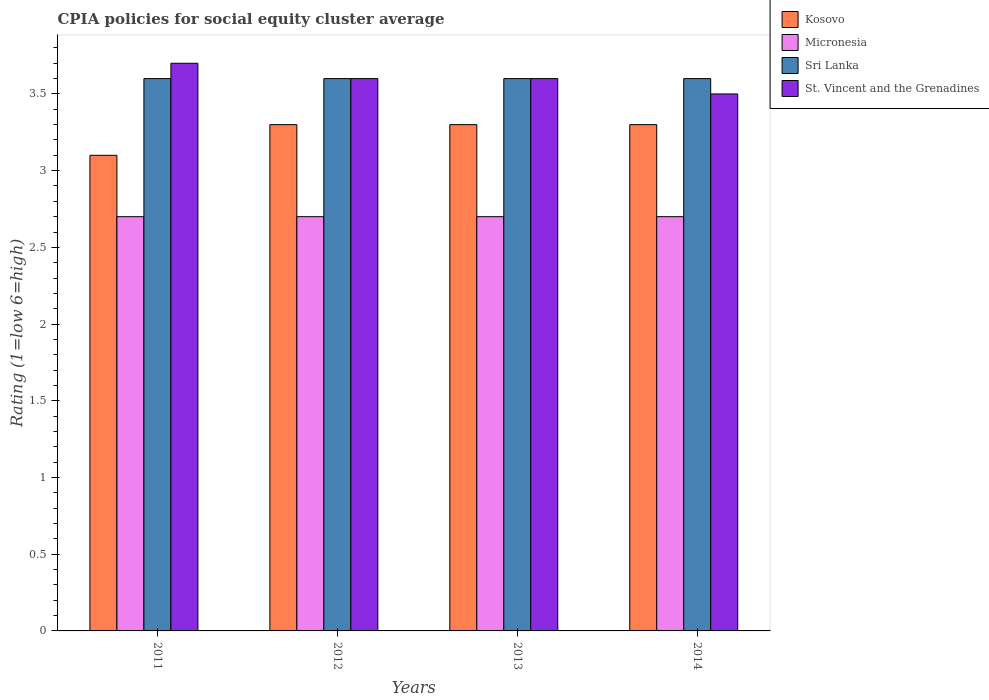How many different coloured bars are there?
Keep it short and to the point. 4. How many bars are there on the 2nd tick from the left?
Your answer should be very brief. 4. How many bars are there on the 1st tick from the right?
Offer a terse response. 4. In how many cases, is the number of bars for a given year not equal to the number of legend labels?
Offer a very short reply. 0. What is the CPIA rating in Kosovo in 2012?
Provide a succinct answer. 3.3. Across all years, what is the maximum CPIA rating in Micronesia?
Offer a terse response. 2.7. Across all years, what is the minimum CPIA rating in Kosovo?
Your answer should be compact. 3.1. In which year was the CPIA rating in Sri Lanka maximum?
Your answer should be very brief. 2011. What is the total CPIA rating in Kosovo in the graph?
Provide a short and direct response. 13. What is the difference between the CPIA rating in St. Vincent and the Grenadines in 2014 and the CPIA rating in Kosovo in 2013?
Keep it short and to the point. 0.2. In the year 2014, what is the difference between the CPIA rating in Sri Lanka and CPIA rating in Micronesia?
Give a very brief answer. 0.9. In how many years, is the CPIA rating in Sri Lanka greater than 2.7?
Ensure brevity in your answer.  4. What is the ratio of the CPIA rating in Kosovo in 2011 to that in 2012?
Your response must be concise. 0.94. What is the difference between the highest and the second highest CPIA rating in St. Vincent and the Grenadines?
Provide a succinct answer. 0.1. What is the difference between the highest and the lowest CPIA rating in St. Vincent and the Grenadines?
Make the answer very short. 0.2. In how many years, is the CPIA rating in Micronesia greater than the average CPIA rating in Micronesia taken over all years?
Provide a short and direct response. 0. Is it the case that in every year, the sum of the CPIA rating in Sri Lanka and CPIA rating in St. Vincent and the Grenadines is greater than the sum of CPIA rating in Kosovo and CPIA rating in Micronesia?
Your response must be concise. Yes. What does the 3rd bar from the left in 2012 represents?
Provide a succinct answer. Sri Lanka. What does the 1st bar from the right in 2012 represents?
Provide a succinct answer. St. Vincent and the Grenadines. Is it the case that in every year, the sum of the CPIA rating in Kosovo and CPIA rating in Sri Lanka is greater than the CPIA rating in Micronesia?
Offer a terse response. Yes. How many bars are there?
Your answer should be compact. 16. What is the difference between two consecutive major ticks on the Y-axis?
Keep it short and to the point. 0.5. How many legend labels are there?
Offer a very short reply. 4. How are the legend labels stacked?
Ensure brevity in your answer.  Vertical. What is the title of the graph?
Your response must be concise. CPIA policies for social equity cluster average. Does "India" appear as one of the legend labels in the graph?
Make the answer very short. No. What is the label or title of the X-axis?
Give a very brief answer. Years. What is the Rating (1=low 6=high) of Micronesia in 2011?
Your response must be concise. 2.7. What is the Rating (1=low 6=high) in Sri Lanka in 2012?
Keep it short and to the point. 3.6. What is the Rating (1=low 6=high) in Kosovo in 2013?
Ensure brevity in your answer.  3.3. What is the Rating (1=low 6=high) of Sri Lanka in 2013?
Provide a short and direct response. 3.6. What is the Rating (1=low 6=high) of St. Vincent and the Grenadines in 2014?
Offer a terse response. 3.5. Across all years, what is the maximum Rating (1=low 6=high) in Kosovo?
Provide a short and direct response. 3.3. Across all years, what is the maximum Rating (1=low 6=high) in Micronesia?
Offer a terse response. 2.7. Across all years, what is the maximum Rating (1=low 6=high) in Sri Lanka?
Your answer should be very brief. 3.6. Across all years, what is the maximum Rating (1=low 6=high) of St. Vincent and the Grenadines?
Make the answer very short. 3.7. Across all years, what is the minimum Rating (1=low 6=high) in Kosovo?
Keep it short and to the point. 3.1. Across all years, what is the minimum Rating (1=low 6=high) of Micronesia?
Ensure brevity in your answer.  2.7. Across all years, what is the minimum Rating (1=low 6=high) in St. Vincent and the Grenadines?
Give a very brief answer. 3.5. What is the total Rating (1=low 6=high) in St. Vincent and the Grenadines in the graph?
Offer a terse response. 14.4. What is the difference between the Rating (1=low 6=high) of Kosovo in 2011 and that in 2012?
Keep it short and to the point. -0.2. What is the difference between the Rating (1=low 6=high) of Micronesia in 2011 and that in 2012?
Your response must be concise. 0. What is the difference between the Rating (1=low 6=high) of St. Vincent and the Grenadines in 2011 and that in 2012?
Offer a terse response. 0.1. What is the difference between the Rating (1=low 6=high) of Kosovo in 2011 and that in 2013?
Offer a terse response. -0.2. What is the difference between the Rating (1=low 6=high) of Micronesia in 2011 and that in 2014?
Provide a short and direct response. 0. What is the difference between the Rating (1=low 6=high) in Sri Lanka in 2011 and that in 2014?
Your answer should be very brief. 0. What is the difference between the Rating (1=low 6=high) in St. Vincent and the Grenadines in 2011 and that in 2014?
Offer a very short reply. 0.2. What is the difference between the Rating (1=low 6=high) of Kosovo in 2012 and that in 2013?
Offer a very short reply. 0. What is the difference between the Rating (1=low 6=high) in Sri Lanka in 2012 and that in 2013?
Offer a terse response. 0. What is the difference between the Rating (1=low 6=high) in Kosovo in 2012 and that in 2014?
Provide a succinct answer. 0. What is the difference between the Rating (1=low 6=high) in Sri Lanka in 2012 and that in 2014?
Your answer should be very brief. 0. What is the difference between the Rating (1=low 6=high) in St. Vincent and the Grenadines in 2013 and that in 2014?
Offer a very short reply. 0.1. What is the difference between the Rating (1=low 6=high) in Kosovo in 2011 and the Rating (1=low 6=high) in Sri Lanka in 2012?
Keep it short and to the point. -0.5. What is the difference between the Rating (1=low 6=high) of Micronesia in 2011 and the Rating (1=low 6=high) of St. Vincent and the Grenadines in 2012?
Give a very brief answer. -0.9. What is the difference between the Rating (1=low 6=high) of Sri Lanka in 2011 and the Rating (1=low 6=high) of St. Vincent and the Grenadines in 2012?
Give a very brief answer. 0. What is the difference between the Rating (1=low 6=high) in Kosovo in 2011 and the Rating (1=low 6=high) in Sri Lanka in 2013?
Ensure brevity in your answer.  -0.5. What is the difference between the Rating (1=low 6=high) of Kosovo in 2011 and the Rating (1=low 6=high) of St. Vincent and the Grenadines in 2013?
Provide a short and direct response. -0.5. What is the difference between the Rating (1=low 6=high) in Micronesia in 2011 and the Rating (1=low 6=high) in St. Vincent and the Grenadines in 2013?
Give a very brief answer. -0.9. What is the difference between the Rating (1=low 6=high) of Kosovo in 2011 and the Rating (1=low 6=high) of Micronesia in 2014?
Keep it short and to the point. 0.4. What is the difference between the Rating (1=low 6=high) of Micronesia in 2011 and the Rating (1=low 6=high) of Sri Lanka in 2014?
Give a very brief answer. -0.9. What is the difference between the Rating (1=low 6=high) in Kosovo in 2012 and the Rating (1=low 6=high) in Micronesia in 2013?
Give a very brief answer. 0.6. What is the difference between the Rating (1=low 6=high) in Kosovo in 2012 and the Rating (1=low 6=high) in St. Vincent and the Grenadines in 2013?
Offer a very short reply. -0.3. What is the difference between the Rating (1=low 6=high) of Micronesia in 2012 and the Rating (1=low 6=high) of Sri Lanka in 2013?
Your response must be concise. -0.9. What is the difference between the Rating (1=low 6=high) of Micronesia in 2012 and the Rating (1=low 6=high) of St. Vincent and the Grenadines in 2013?
Your response must be concise. -0.9. What is the difference between the Rating (1=low 6=high) of Kosovo in 2012 and the Rating (1=low 6=high) of Sri Lanka in 2014?
Offer a very short reply. -0.3. What is the difference between the Rating (1=low 6=high) in Micronesia in 2012 and the Rating (1=low 6=high) in Sri Lanka in 2014?
Offer a terse response. -0.9. What is the difference between the Rating (1=low 6=high) of Micronesia in 2012 and the Rating (1=low 6=high) of St. Vincent and the Grenadines in 2014?
Offer a very short reply. -0.8. What is the difference between the Rating (1=low 6=high) in Sri Lanka in 2012 and the Rating (1=low 6=high) in St. Vincent and the Grenadines in 2014?
Give a very brief answer. 0.1. What is the difference between the Rating (1=low 6=high) in Kosovo in 2013 and the Rating (1=low 6=high) in Micronesia in 2014?
Your answer should be very brief. 0.6. What is the difference between the Rating (1=low 6=high) of Kosovo in 2013 and the Rating (1=low 6=high) of Sri Lanka in 2014?
Give a very brief answer. -0.3. What is the difference between the Rating (1=low 6=high) of Sri Lanka in 2013 and the Rating (1=low 6=high) of St. Vincent and the Grenadines in 2014?
Ensure brevity in your answer.  0.1. What is the average Rating (1=low 6=high) in Micronesia per year?
Provide a short and direct response. 2.7. What is the average Rating (1=low 6=high) of Sri Lanka per year?
Make the answer very short. 3.6. In the year 2011, what is the difference between the Rating (1=low 6=high) of Micronesia and Rating (1=low 6=high) of Sri Lanka?
Ensure brevity in your answer.  -0.9. In the year 2012, what is the difference between the Rating (1=low 6=high) in Kosovo and Rating (1=low 6=high) in St. Vincent and the Grenadines?
Provide a short and direct response. -0.3. In the year 2012, what is the difference between the Rating (1=low 6=high) in Sri Lanka and Rating (1=low 6=high) in St. Vincent and the Grenadines?
Provide a short and direct response. 0. In the year 2013, what is the difference between the Rating (1=low 6=high) in Kosovo and Rating (1=low 6=high) in Micronesia?
Ensure brevity in your answer.  0.6. In the year 2013, what is the difference between the Rating (1=low 6=high) in Kosovo and Rating (1=low 6=high) in Sri Lanka?
Provide a succinct answer. -0.3. In the year 2013, what is the difference between the Rating (1=low 6=high) in Micronesia and Rating (1=low 6=high) in Sri Lanka?
Offer a terse response. -0.9. In the year 2013, what is the difference between the Rating (1=low 6=high) of Micronesia and Rating (1=low 6=high) of St. Vincent and the Grenadines?
Provide a succinct answer. -0.9. In the year 2014, what is the difference between the Rating (1=low 6=high) of Kosovo and Rating (1=low 6=high) of Micronesia?
Ensure brevity in your answer.  0.6. In the year 2014, what is the difference between the Rating (1=low 6=high) of Kosovo and Rating (1=low 6=high) of Sri Lanka?
Give a very brief answer. -0.3. In the year 2014, what is the difference between the Rating (1=low 6=high) of Micronesia and Rating (1=low 6=high) of Sri Lanka?
Give a very brief answer. -0.9. What is the ratio of the Rating (1=low 6=high) in Kosovo in 2011 to that in 2012?
Your answer should be compact. 0.94. What is the ratio of the Rating (1=low 6=high) in Sri Lanka in 2011 to that in 2012?
Offer a terse response. 1. What is the ratio of the Rating (1=low 6=high) in St. Vincent and the Grenadines in 2011 to that in 2012?
Provide a succinct answer. 1.03. What is the ratio of the Rating (1=low 6=high) of Kosovo in 2011 to that in 2013?
Ensure brevity in your answer.  0.94. What is the ratio of the Rating (1=low 6=high) of Sri Lanka in 2011 to that in 2013?
Offer a very short reply. 1. What is the ratio of the Rating (1=low 6=high) in St. Vincent and the Grenadines in 2011 to that in 2013?
Your answer should be very brief. 1.03. What is the ratio of the Rating (1=low 6=high) in Kosovo in 2011 to that in 2014?
Make the answer very short. 0.94. What is the ratio of the Rating (1=low 6=high) of Micronesia in 2011 to that in 2014?
Keep it short and to the point. 1. What is the ratio of the Rating (1=low 6=high) of St. Vincent and the Grenadines in 2011 to that in 2014?
Your response must be concise. 1.06. What is the ratio of the Rating (1=low 6=high) in Sri Lanka in 2012 to that in 2013?
Your response must be concise. 1. What is the ratio of the Rating (1=low 6=high) of St. Vincent and the Grenadines in 2012 to that in 2013?
Keep it short and to the point. 1. What is the ratio of the Rating (1=low 6=high) in Kosovo in 2012 to that in 2014?
Provide a succinct answer. 1. What is the ratio of the Rating (1=low 6=high) in St. Vincent and the Grenadines in 2012 to that in 2014?
Your answer should be compact. 1.03. What is the ratio of the Rating (1=low 6=high) of Sri Lanka in 2013 to that in 2014?
Provide a short and direct response. 1. What is the ratio of the Rating (1=low 6=high) in St. Vincent and the Grenadines in 2013 to that in 2014?
Ensure brevity in your answer.  1.03. What is the difference between the highest and the second highest Rating (1=low 6=high) in Kosovo?
Your answer should be very brief. 0. What is the difference between the highest and the second highest Rating (1=low 6=high) of Micronesia?
Your response must be concise. 0. What is the difference between the highest and the second highest Rating (1=low 6=high) in St. Vincent and the Grenadines?
Ensure brevity in your answer.  0.1. What is the difference between the highest and the lowest Rating (1=low 6=high) in Kosovo?
Give a very brief answer. 0.2. What is the difference between the highest and the lowest Rating (1=low 6=high) of Sri Lanka?
Provide a short and direct response. 0. 